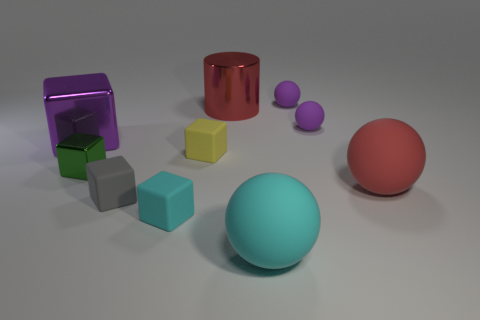Subtract 1 blocks. How many blocks are left? 4 Subtract all gray cubes. How many cubes are left? 4 Subtract all yellow blocks. How many blocks are left? 4 Subtract all gray spheres. Subtract all gray blocks. How many spheres are left? 4 Subtract all cylinders. How many objects are left? 9 Add 4 cyan rubber cylinders. How many cyan rubber cylinders exist? 4 Subtract 1 yellow cubes. How many objects are left? 9 Subtract all green blocks. Subtract all tiny purple cylinders. How many objects are left? 9 Add 6 large red shiny things. How many large red shiny things are left? 7 